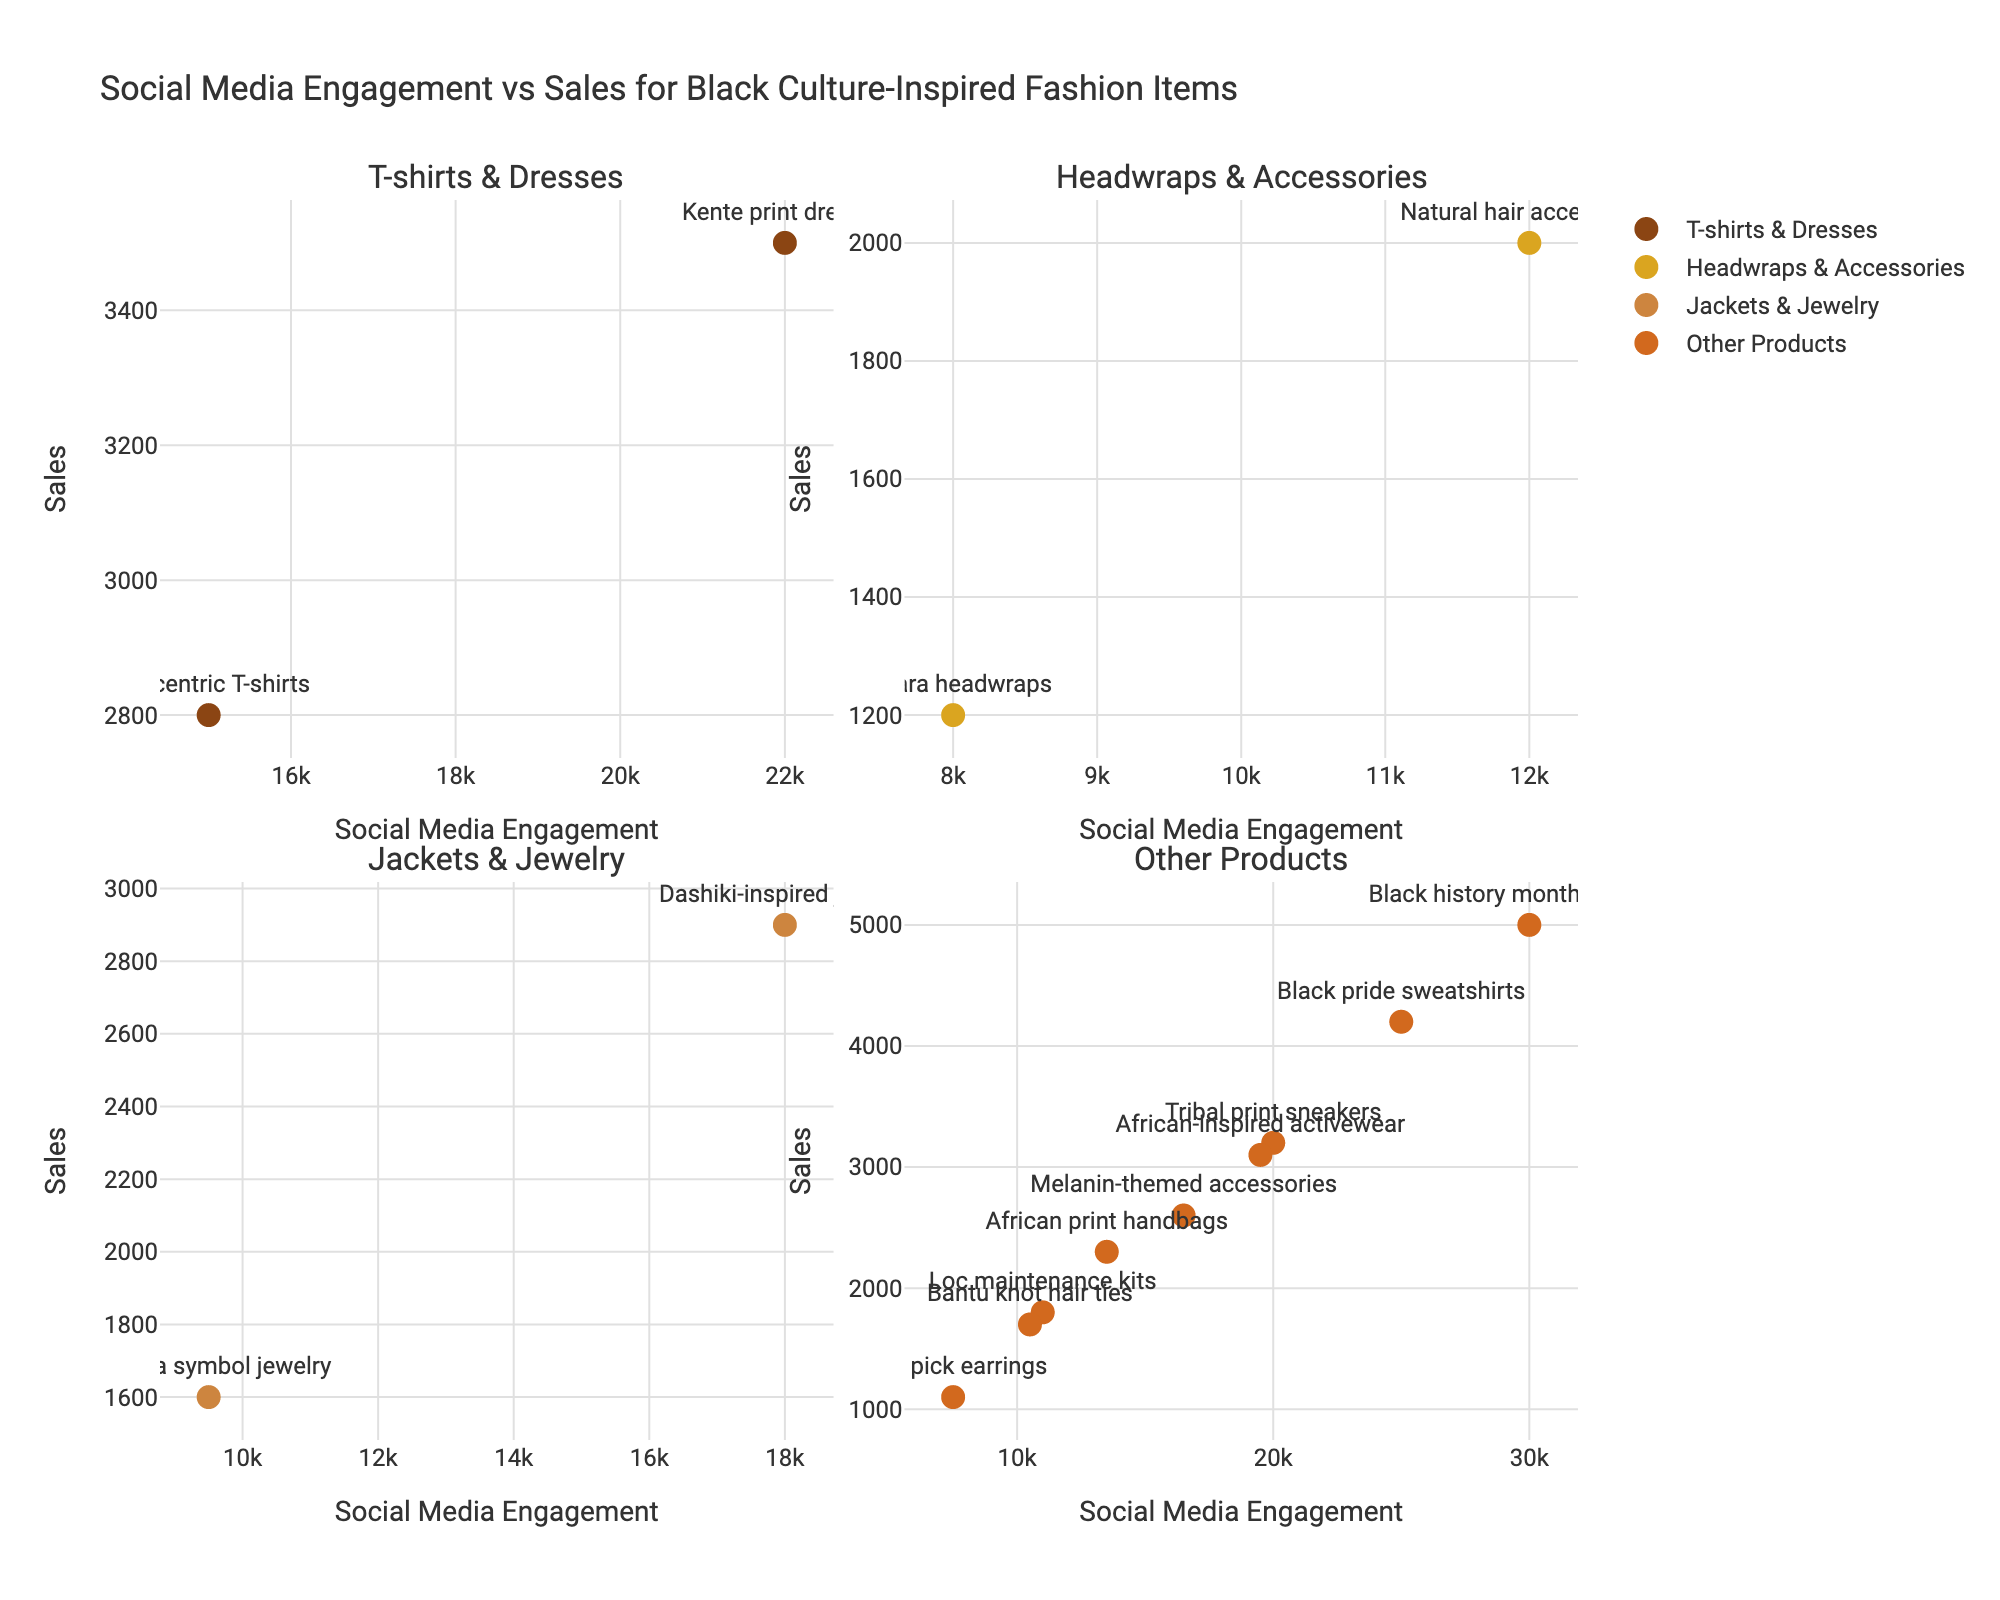What's the title of the figure? The title is displayed at the top center of the plot. It gives the context for what's being visualized. In this case, it's "Social Media Engagement vs Sales for Black Culture-Inspired Fashion Items."
Answer: Social Media Engagement vs Sales for Black Culture-Inspired Fashion Items How many subplots are there in the figure? The figure consists of four distinct areas or sections, known as subplots. These are visually separated and individually titled: 'T-shirts & Dresses', 'Headwraps & Accessories', 'Jackets & Jewelry', and 'Other Products'.
Answer: 4 Which product within the 'T-shirts & Dresses' subplot has higher social media engagement? In the 'T-shirts & Dresses' subplot (top-left), there are two points labeled "Afrocentric T-shirts" and "Kente print dresses." By inspecting the x-values, "Kente print dresses" has higher social media engagement.
Answer: Kente print dresses Which subplot contains the product with the highest sales overall? Looking across all four subplots, we identify the product with the highest y-value (sales). The 'Other Products' subplot (bottom-right) contains the "Black history month collection" product, which has the highest sales overall.
Answer: Other Products Compare the 'Dashiki-inspired jackets' and 'Adinkra symbol jewelry' in terms of social media engagement and sales. Which one is higher in both metrics? In the 'Jackets & Jewelry' subplot (bottom-left), the x (social media engagement) and y (sales) values for these two products show that 'Dashiki-inspired jackets' have higher values in both metrics compared to 'Adinkra symbol jewelry'.
Answer: Dashiki-inspired jackets What's the total sales of 'Ankara headwraps' and 'Natural hair accessories'? First, identify the y-values (sales) for 'Ankara headwraps' (1200) and 'Natural hair accessories' (2000) from the 'Headwraps & Accessories' subplot (top-right). Sum these values: 1200 + 2000 = 3200.
Answer: 3200 Is there a positive correlation between social media engagement and sales for 'Other Products'? To determine correlation within the 'Other Products' subplot (bottom-right), observe the trend of data points. They generally appear to increase together, indicating a positive correlation.
Answer: Yes Identify the product with the lowest sales in the 'Jackets & Jewelry' subplot. In the 'Jackets & Jewelry' subplot (bottom-left), comparing the y-values (sales) of the points, 'Adinkra symbol jewelry' has the lowest sales.
Answer: Adinkra symbol jewelry Which product among 'Other Products' has the lowest social media engagement? In the 'Other Products' subplot (bottom-right), by comparing the x-values (social media engagement), 'Afro pick earrings' has the lowest engagement.
Answer: Afro pick earrings 